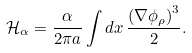<formula> <loc_0><loc_0><loc_500><loc_500>\mathcal { H } _ { \alpha } = \frac { \alpha } { 2 \pi a } \int d x \, \frac { \left ( \nabla \phi _ { \rho } \right ) ^ { 3 } } { 2 } .</formula> 